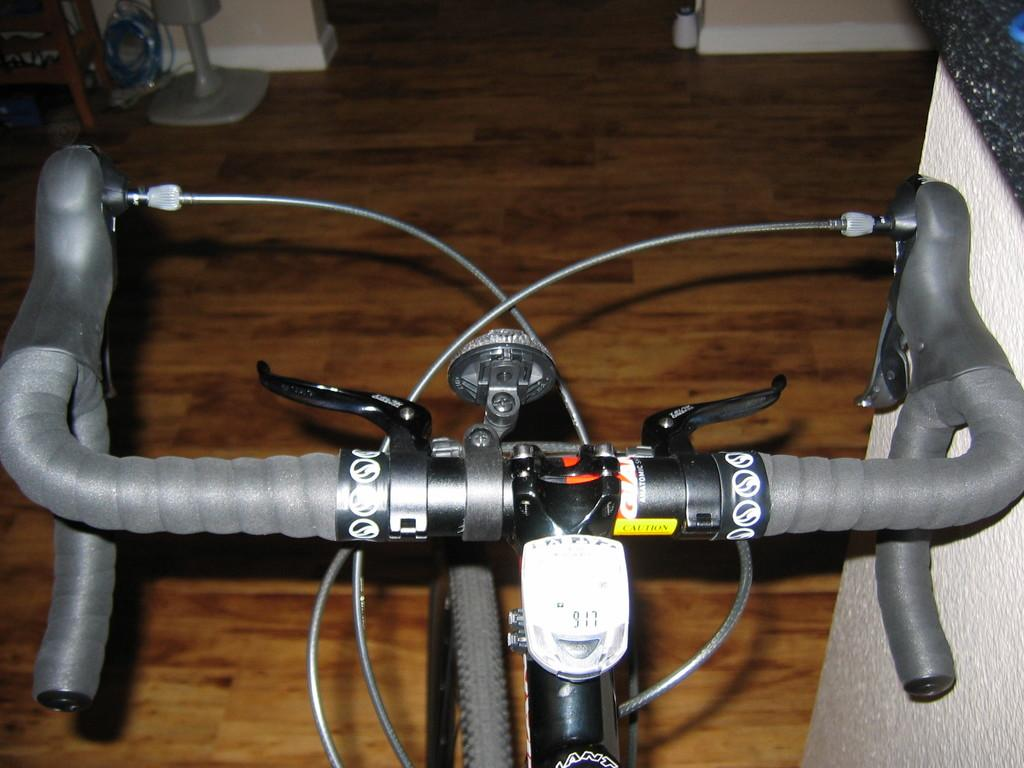What object is featured in the foreground of the image? There is a handle of a bicycle in the image. What type of surface is visible in the background of the image? There is a floor visible in the background of the image. What can be seen on the floor in the background? There are things placed on the floor in the background. What is located on the right side of the image? There is a wall on the right side of the image. What type of fiction is the uncle reading on the floor in the image? There is no uncle or fiction present in the image; it only features a bicycle handle, a floor, and a wall. How many grapes are visible on the wall in the image? There are no grapes present in the image; it only features a bicycle handle, a floor, and a wall. 